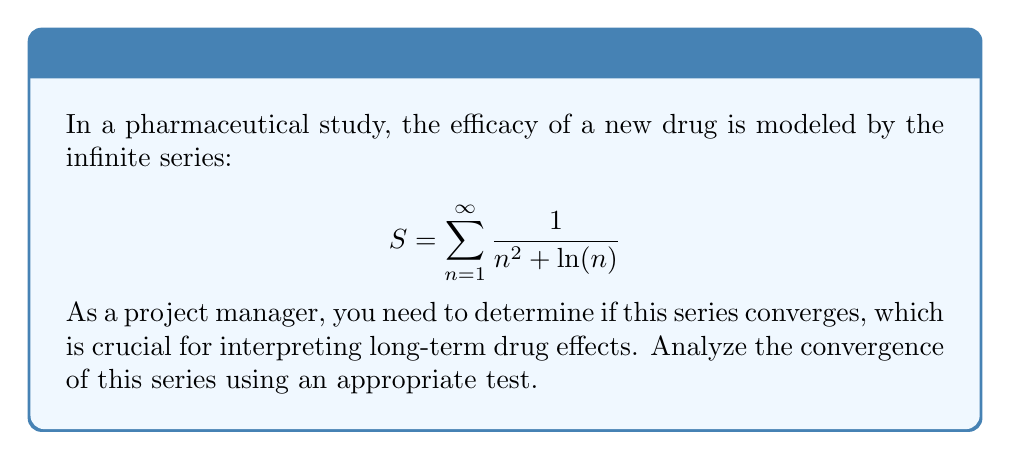What is the answer to this math problem? To analyze the convergence of this series, we'll use the comparison test with a known convergent series. Let's approach this step-by-step:

1) First, observe that for $n \geq 3$, $\ln(n) < n$. This is because the natural logarithm grows slower than linear functions for large n.

2) Using this observation, we can say that for $n \geq 3$:

   $$\frac{1}{n^2 + \ln(n)} < \frac{1}{n^2 + n}$$

3) Now, let's compare our series to the series $\sum_{n=1}^{\infty} \frac{1}{n^2}$, which is the well-known p-series with $p=2$. We know this series converges (it's actually $\frac{\pi^2}{6}$).

4) For $n \geq 3$, we have:

   $$\frac{1}{n^2 + n} < \frac{1}{n^2}$$

5) Combining steps 2 and 4, we get:

   $$\frac{1}{n^2 + \ln(n)} < \frac{1}{n^2 + n} < \frac{1}{n^2}$$

6) By the comparison test, since $\frac{1}{n^2 + \ln(n)} < \frac{1}{n^2}$ for all $n \geq 3$, and $\sum_{n=1}^{\infty} \frac{1}{n^2}$ converges, our original series $\sum_{n=1}^{\infty} \frac{1}{n^2 + \ln(n)}$ must also converge.

7) The first two terms of our series ($n=1$ and $n=2$) don't affect the convergence of the infinite series, so we can ignore them in this analysis.

Therefore, we can conclude that the series representing the drug efficacy data converges.
Answer: The series converges. 